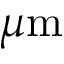<formula> <loc_0><loc_0><loc_500><loc_500>\mu m</formula> 